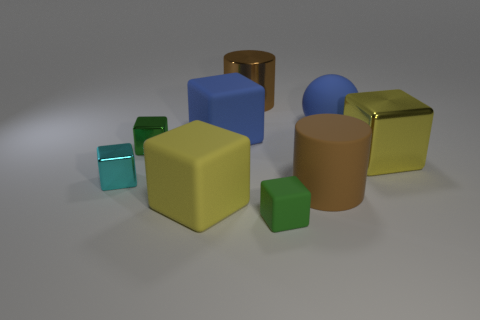There is a cube that is both to the right of the large brown metallic cylinder and left of the large blue rubber sphere; how big is it?
Keep it short and to the point. Small. Do the blue ball and the big yellow thing on the right side of the yellow matte thing have the same material?
Your answer should be compact. No. How many yellow rubber things are the same shape as the cyan object?
Ensure brevity in your answer.  1. There is another large cylinder that is the same color as the metal cylinder; what material is it?
Ensure brevity in your answer.  Rubber. What number of big purple balls are there?
Ensure brevity in your answer.  0. Do the yellow matte thing and the green object left of the small rubber cube have the same shape?
Offer a very short reply. Yes. How many things are small cyan shiny things or big objects that are in front of the blue rubber ball?
Offer a terse response. 5. There is a large blue thing that is the same shape as the small cyan object; what is its material?
Provide a short and direct response. Rubber. Do the large matte object on the left side of the large blue matte block and the green shiny thing have the same shape?
Provide a short and direct response. Yes. Is the number of cyan blocks in front of the matte cylinder less than the number of brown matte things that are behind the yellow shiny thing?
Your answer should be compact. No. 